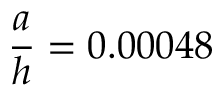<formula> <loc_0><loc_0><loc_500><loc_500>\frac { a } { h } = 0 . 0 0 0 4 8</formula> 